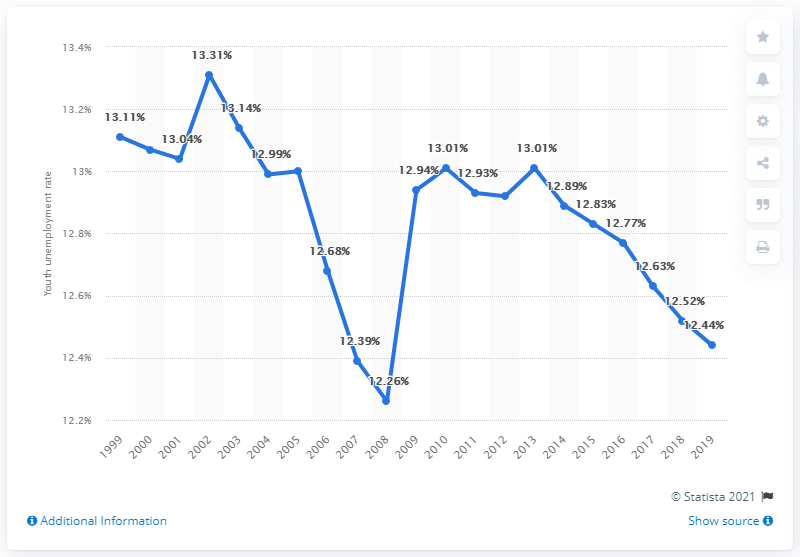What can be inferred about economic conditions in Gambia from this unemployment timeline? From the provided timeline of youth unemployment rates, it can be inferred that the economic conditions in Gambia have been somewhat unstable. The periodic fluctuations in the unemployment rates suggest varying phases of economic growth and challenges. The peaks and troughs in the unemployment rate could correlate with policy changes, economic reforms, or external economic pressures. 